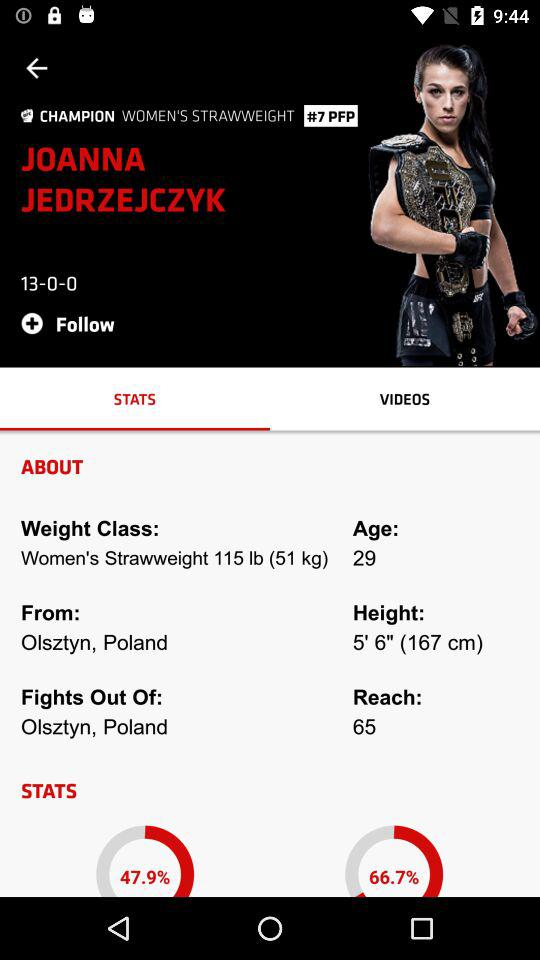What is the score? The score is 13-0-0. 